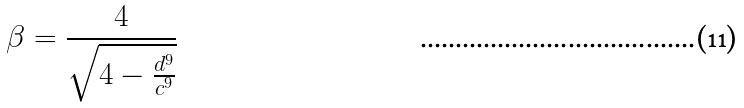Convert formula to latex. <formula><loc_0><loc_0><loc_500><loc_500>\beta = \frac { 4 } { \sqrt { 4 - \frac { d ^ { 9 } } { c ^ { 9 } } } }</formula> 